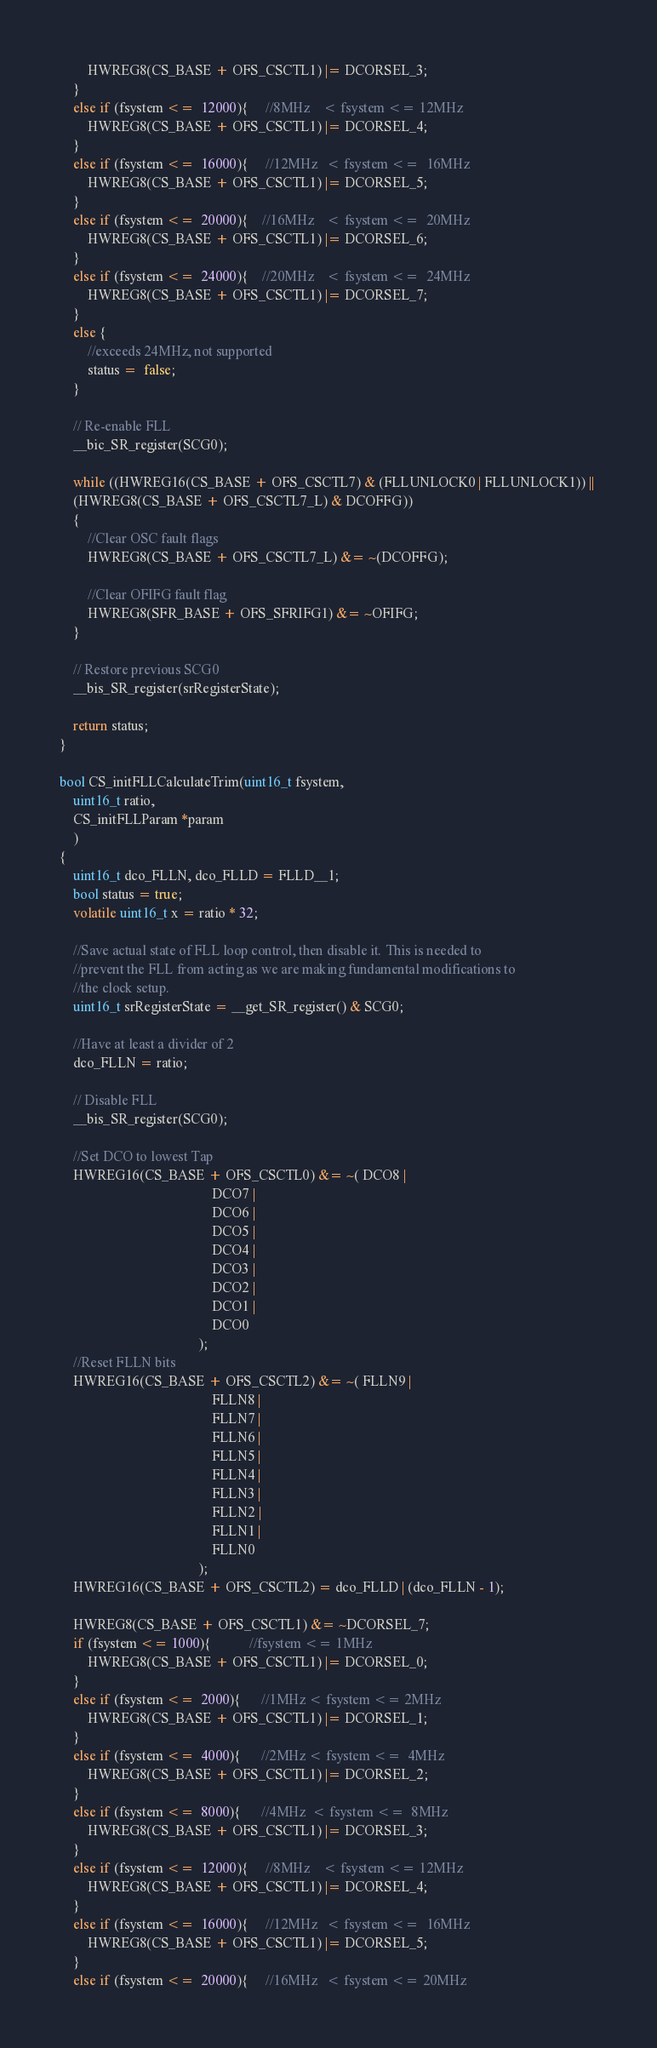Convert code to text. <code><loc_0><loc_0><loc_500><loc_500><_C_>        HWREG8(CS_BASE + OFS_CSCTL1) |= DCORSEL_3;
    }
    else if (fsystem <=  12000){     //8MHz    < fsystem <= 12MHz
        HWREG8(CS_BASE + OFS_CSCTL1) |= DCORSEL_4;
    }
    else if (fsystem <=  16000){     //12MHz   < fsystem <=  16MHz
        HWREG8(CS_BASE + OFS_CSCTL1) |= DCORSEL_5;
    }
    else if (fsystem <=  20000){    //16MHz    < fsystem <=  20MHz
        HWREG8(CS_BASE + OFS_CSCTL1) |= DCORSEL_6;
    }
    else if (fsystem <=  24000){    //20MHz    < fsystem <=  24MHz
        HWREG8(CS_BASE + OFS_CSCTL1) |= DCORSEL_7;
    }
    else {
    	//exceeds 24MHz, not supported
    	status =  false;
    }

    // Re-enable FLL
    __bic_SR_register(SCG0);
    
    while ((HWREG16(CS_BASE + OFS_CSCTL7) & (FLLUNLOCK0 | FLLUNLOCK1)) || 
    (HWREG8(CS_BASE + OFS_CSCTL7_L) & DCOFFG))
    {
        //Clear OSC fault flags
        HWREG8(CS_BASE + OFS_CSCTL7_L) &= ~(DCOFFG);

        //Clear OFIFG fault flag
        HWREG8(SFR_BASE + OFS_SFRIFG1) &= ~OFIFG;
    }

    // Restore previous SCG0
    __bis_SR_register(srRegisterState);
    
    return status;
}

bool CS_initFLLCalculateTrim(uint16_t fsystem,
    uint16_t ratio,
    CS_initFLLParam *param
    )
{
    uint16_t dco_FLLN, dco_FLLD = FLLD__1;
    bool status = true;
    volatile uint16_t x = ratio * 32;

    //Save actual state of FLL loop control, then disable it. This is needed to
    //prevent the FLL from acting as we are making fundamental modifications to
    //the clock setup.
    uint16_t srRegisterState = __get_SR_register() & SCG0;

    //Have at least a divider of 2
    dco_FLLN = ratio;

    // Disable FLL
    __bis_SR_register(SCG0);                                    

    //Set DCO to lowest Tap
    HWREG16(CS_BASE + OFS_CSCTL0) &= ~( DCO8 |
                                            DCO7 |
                                            DCO6 |
                                            DCO5 |
                                            DCO4 |
                                            DCO3 |
                                            DCO2 |
                                            DCO1 |
                                            DCO0
                                        );
    //Reset FLLN bits
    HWREG16(CS_BASE + OFS_CSCTL2) &= ~( FLLN9 |
                                            FLLN8 |
                                            FLLN7 |
                                            FLLN6 |
                                            FLLN5 |
                                            FLLN4 |
                                            FLLN3 |
                                            FLLN2 |
                                            FLLN1 |
                                            FLLN0
                                        );
    HWREG16(CS_BASE + OFS_CSCTL2) = dco_FLLD | (dco_FLLN - 1);

    HWREG8(CS_BASE + OFS_CSCTL1) &= ~DCORSEL_7;
    if (fsystem <= 1000){           //fsystem <= 1MHz
        HWREG8(CS_BASE + OFS_CSCTL1) |= DCORSEL_0;
    }
    else if (fsystem <=  2000){      //1MHz < fsystem <= 2MHz
        HWREG8(CS_BASE + OFS_CSCTL1) |= DCORSEL_1;
    }
    else if (fsystem <=  4000){      //2MHz < fsystem <=  4MHz
        HWREG8(CS_BASE + OFS_CSCTL1) |= DCORSEL_2;
    }
    else if (fsystem <=  8000){      //4MHz  < fsystem <=  8MHz
        HWREG8(CS_BASE + OFS_CSCTL1) |= DCORSEL_3;
    }
    else if (fsystem <=  12000){     //8MHz    < fsystem <= 12MHz
        HWREG8(CS_BASE + OFS_CSCTL1) |= DCORSEL_4;
    }
    else if (fsystem <=  16000){     //12MHz   < fsystem <=  16MHz
        HWREG8(CS_BASE + OFS_CSCTL1) |= DCORSEL_5;
    }
    else if (fsystem <=  20000){     //16MHz   < fsystem <= 20MHz</code> 